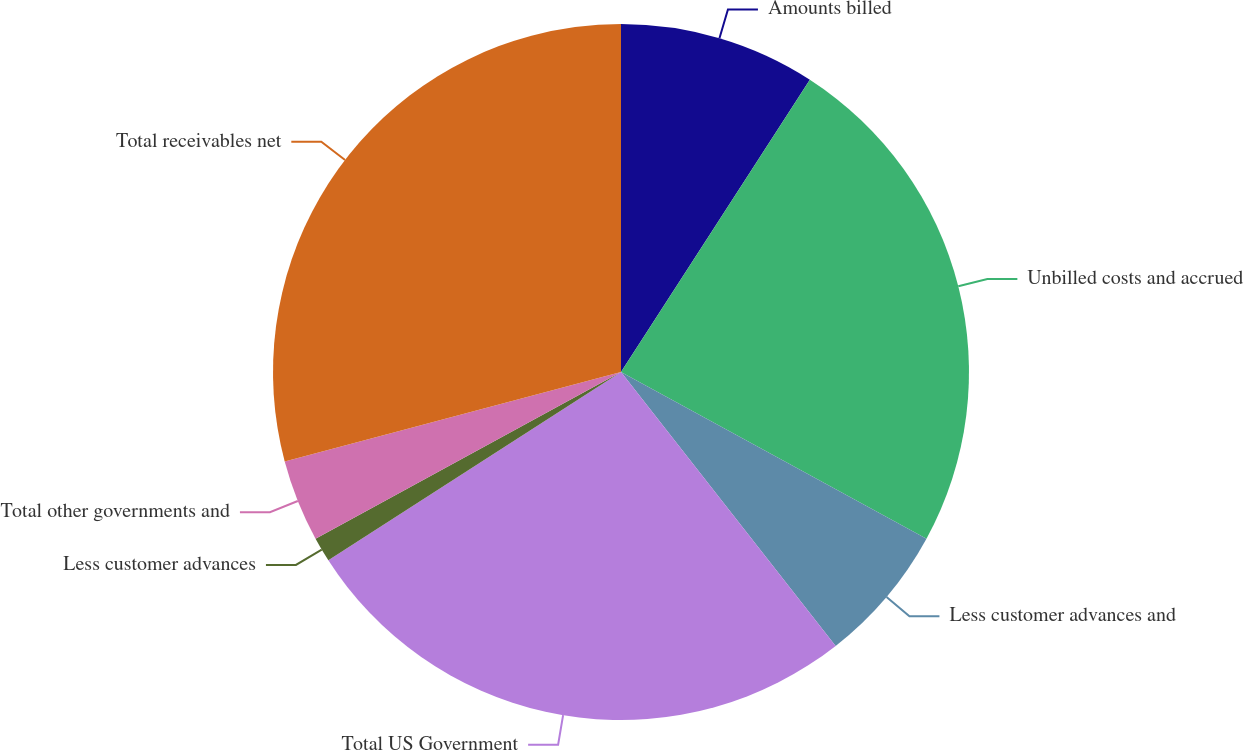Convert chart to OTSL. <chart><loc_0><loc_0><loc_500><loc_500><pie_chart><fcel>Amounts billed<fcel>Unbilled costs and accrued<fcel>Less customer advances and<fcel>Total US Government<fcel>Less customer advances<fcel>Total other governments and<fcel>Total receivables net<nl><fcel>9.13%<fcel>23.82%<fcel>6.47%<fcel>26.48%<fcel>1.15%<fcel>3.81%<fcel>29.14%<nl></chart> 